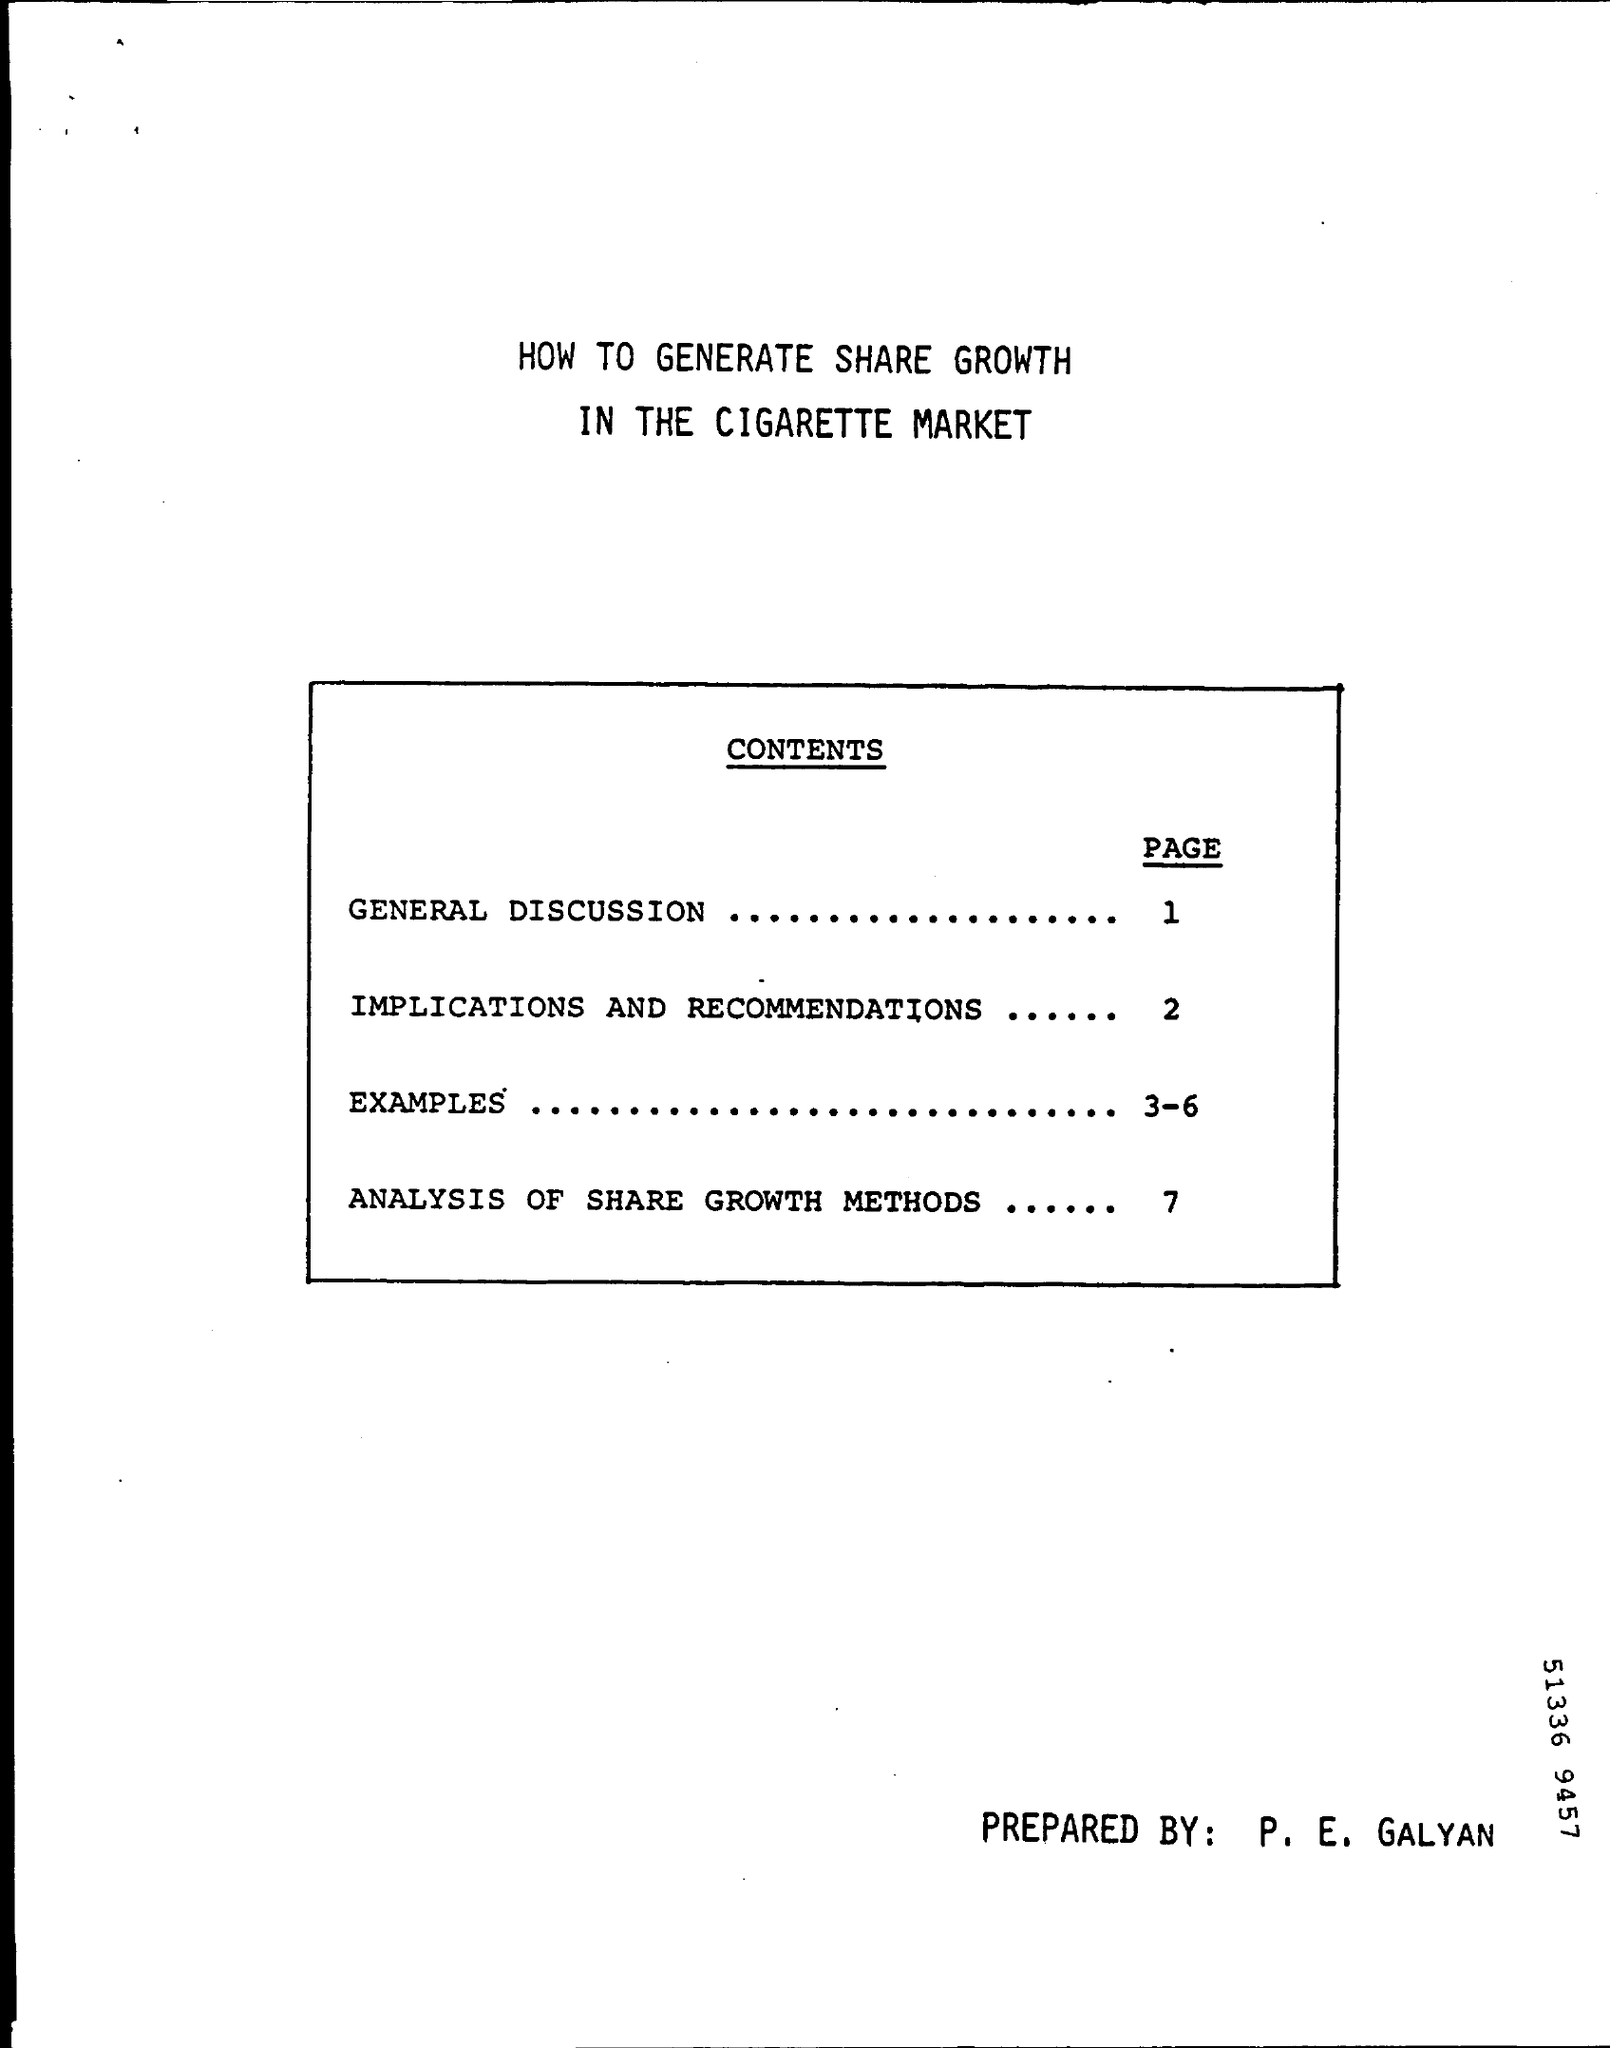What is the page number for examples ?
Your answer should be compact. 3-6. Who is prepared this ?
Make the answer very short. P. E. GALYAN. What is showing Page number "1" ?
Make the answer very short. GENERAL DISCUSSION. 